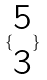Convert formula to latex. <formula><loc_0><loc_0><loc_500><loc_500>\{ \begin{matrix} 5 \\ 3 \end{matrix} \}</formula> 